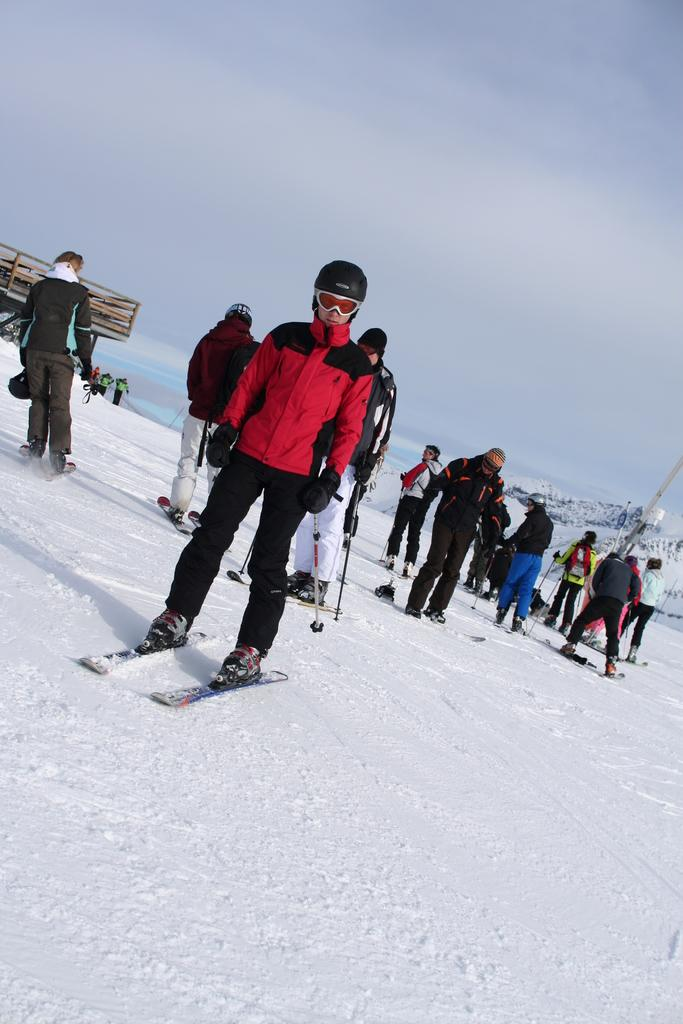What is the man in the image doing? The man is skiing in the image. On what surface is the man skiing? The man is skiing on snow. What can be seen in the background of the image? There are people and hills visible in the background of the image. What is visible at the top of the image? The sky is visible at the top of the image. What type of minister is present in the image? There is no minister present in the image; it features a man skiing on snow. How many toads can be seen in the image? There are no toads present in the image. 